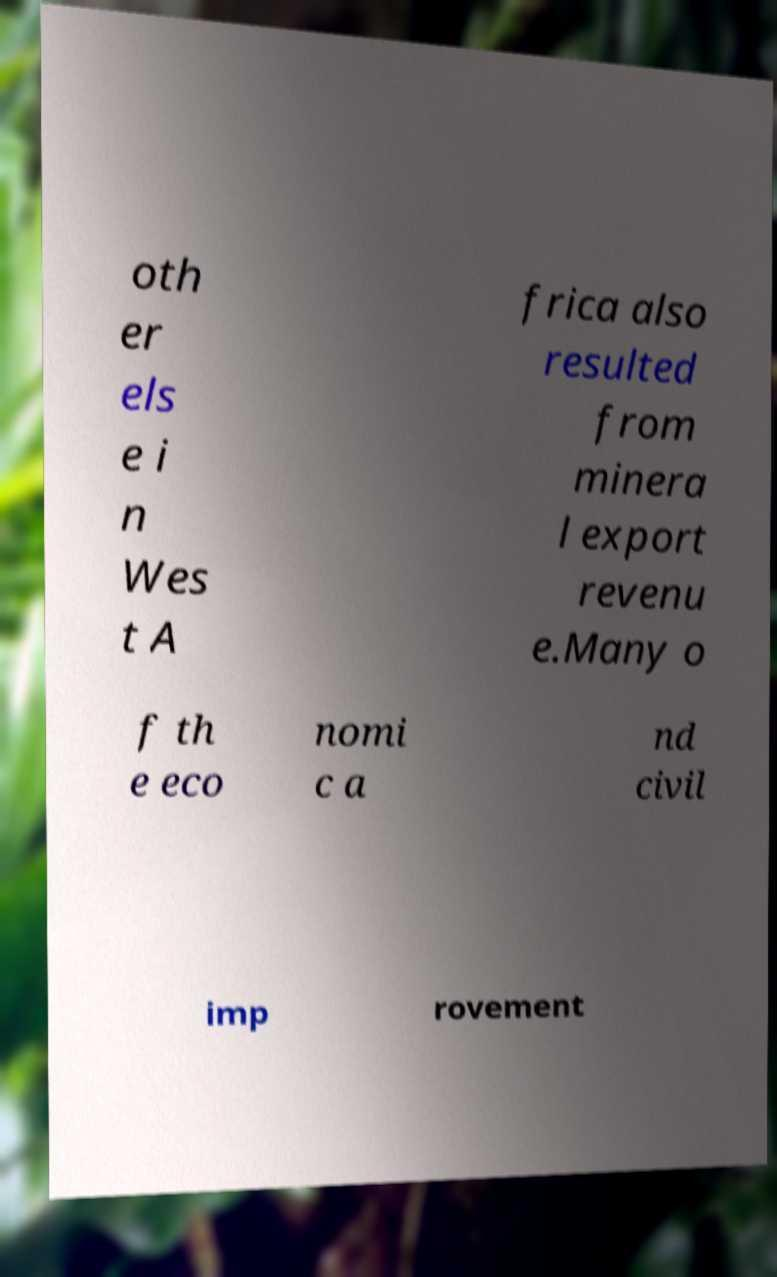Please identify and transcribe the text found in this image. oth er els e i n Wes t A frica also resulted from minera l export revenu e.Many o f th e eco nomi c a nd civil imp rovement 